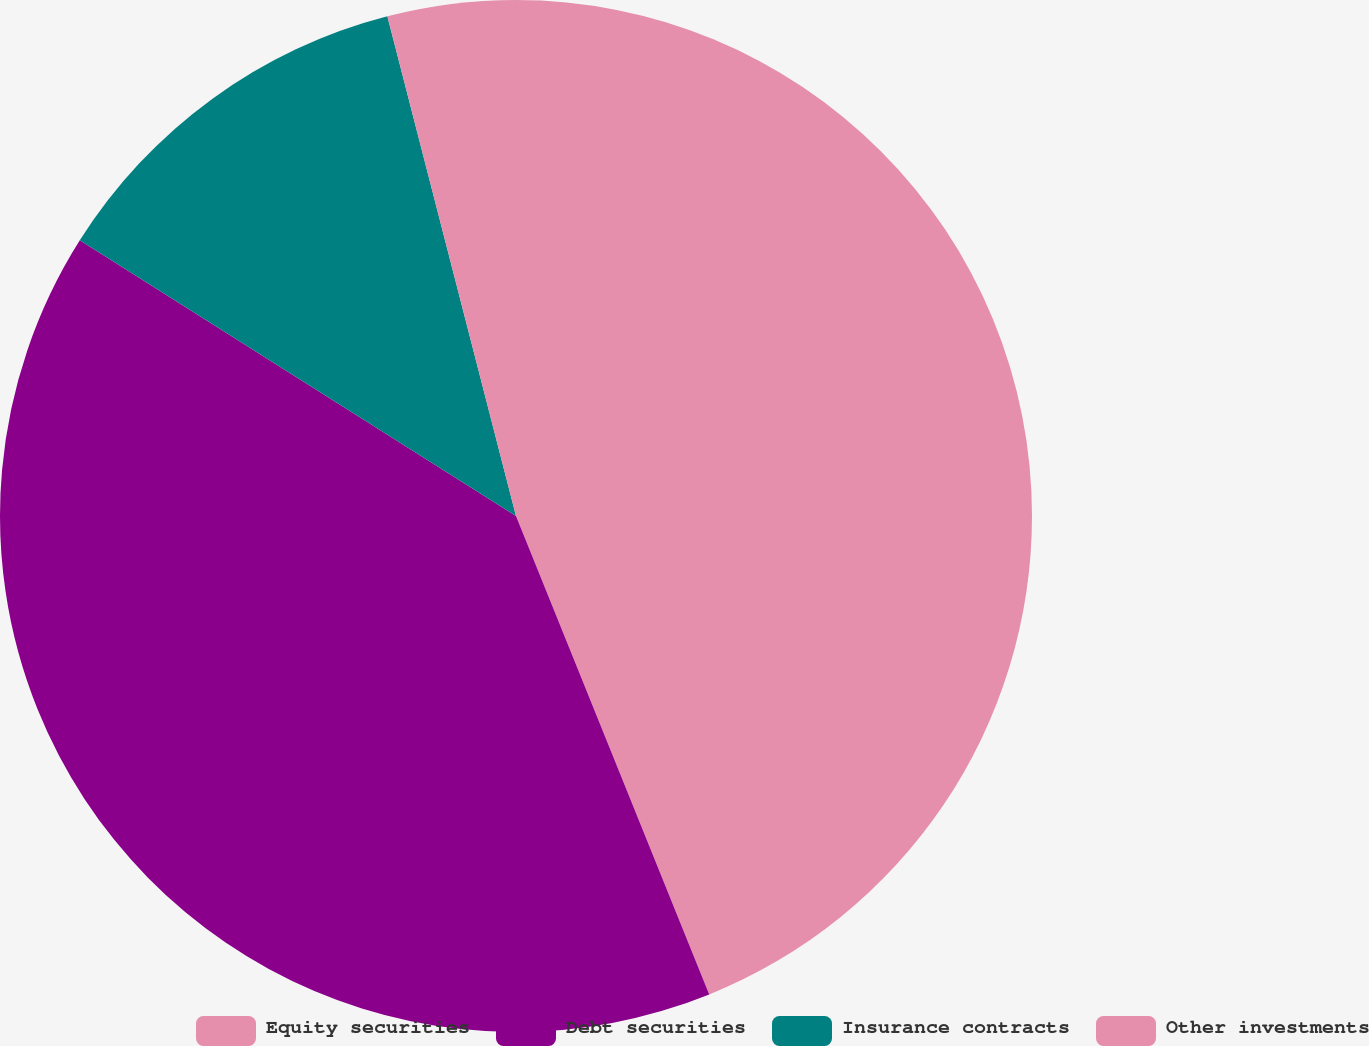<chart> <loc_0><loc_0><loc_500><loc_500><pie_chart><fcel>Equity securities<fcel>Debt securities<fcel>Insurance contracts<fcel>Other investments<nl><fcel>43.89%<fcel>40.08%<fcel>12.02%<fcel>4.01%<nl></chart> 